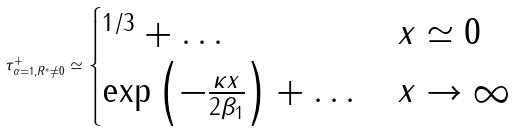Convert formula to latex. <formula><loc_0><loc_0><loc_500><loc_500>\tau _ { \alpha = 1 , R ^ { * } \neq 0 } ^ { + } \simeq \begin{cases} ^ { 1 / 3 } + \dots & x \simeq 0 \\ \exp \left ( - \frac { \kappa x } { 2 \beta _ { 1 } } \right ) + \dots & x \to \infty \end{cases}</formula> 